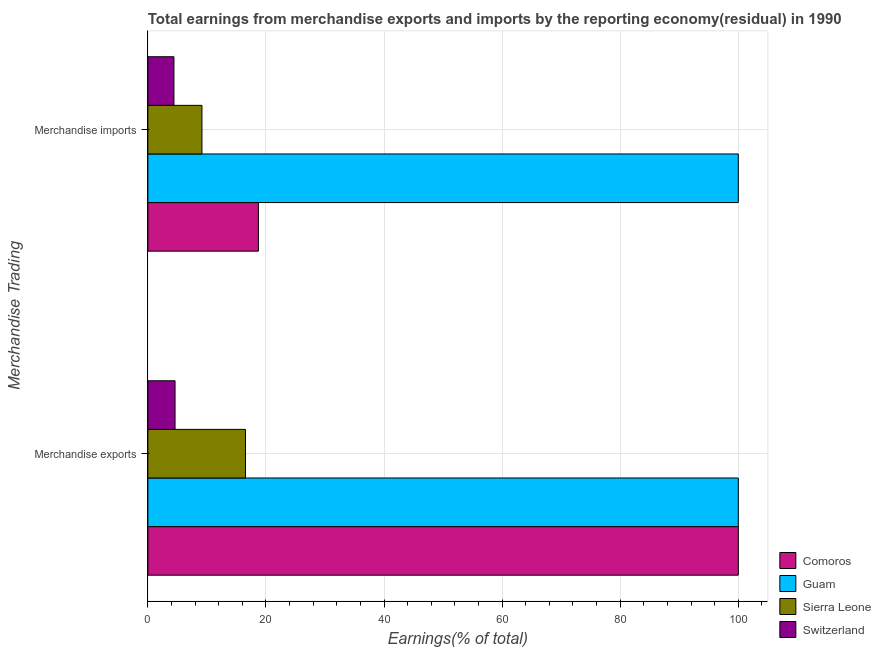How many different coloured bars are there?
Give a very brief answer. 4. How many groups of bars are there?
Ensure brevity in your answer.  2. Are the number of bars on each tick of the Y-axis equal?
Provide a succinct answer. Yes. How many bars are there on the 2nd tick from the top?
Offer a terse response. 4. What is the earnings from merchandise imports in Guam?
Offer a terse response. 100. Across all countries, what is the maximum earnings from merchandise imports?
Give a very brief answer. 100. Across all countries, what is the minimum earnings from merchandise exports?
Your answer should be compact. 4.61. In which country was the earnings from merchandise exports maximum?
Your response must be concise. Comoros. In which country was the earnings from merchandise imports minimum?
Offer a terse response. Switzerland. What is the total earnings from merchandise imports in the graph?
Your answer should be very brief. 132.3. What is the difference between the earnings from merchandise exports in Comoros and that in Guam?
Provide a succinct answer. 0. What is the difference between the earnings from merchandise exports in Guam and the earnings from merchandise imports in Switzerland?
Ensure brevity in your answer.  95.58. What is the average earnings from merchandise imports per country?
Provide a short and direct response. 33.07. What is the difference between the earnings from merchandise imports and earnings from merchandise exports in Comoros?
Offer a terse response. -81.28. In how many countries, is the earnings from merchandise exports greater than 40 %?
Ensure brevity in your answer.  2. What is the ratio of the earnings from merchandise exports in Sierra Leone to that in Guam?
Give a very brief answer. 0.17. Is the earnings from merchandise imports in Comoros less than that in Guam?
Ensure brevity in your answer.  Yes. In how many countries, is the earnings from merchandise exports greater than the average earnings from merchandise exports taken over all countries?
Offer a terse response. 2. What does the 1st bar from the top in Merchandise exports represents?
Offer a terse response. Switzerland. What does the 1st bar from the bottom in Merchandise exports represents?
Offer a terse response. Comoros. Are all the bars in the graph horizontal?
Your response must be concise. Yes. Does the graph contain any zero values?
Ensure brevity in your answer.  No. Where does the legend appear in the graph?
Your response must be concise. Bottom right. How are the legend labels stacked?
Your answer should be very brief. Vertical. What is the title of the graph?
Provide a succinct answer. Total earnings from merchandise exports and imports by the reporting economy(residual) in 1990. Does "Russian Federation" appear as one of the legend labels in the graph?
Give a very brief answer. No. What is the label or title of the X-axis?
Provide a short and direct response. Earnings(% of total). What is the label or title of the Y-axis?
Keep it short and to the point. Merchandise Trading. What is the Earnings(% of total) of Guam in Merchandise exports?
Your response must be concise. 100. What is the Earnings(% of total) in Sierra Leone in Merchandise exports?
Make the answer very short. 16.53. What is the Earnings(% of total) of Switzerland in Merchandise exports?
Ensure brevity in your answer.  4.61. What is the Earnings(% of total) in Comoros in Merchandise imports?
Provide a short and direct response. 18.72. What is the Earnings(% of total) in Sierra Leone in Merchandise imports?
Provide a short and direct response. 9.16. What is the Earnings(% of total) of Switzerland in Merchandise imports?
Ensure brevity in your answer.  4.42. Across all Merchandise Trading, what is the maximum Earnings(% of total) in Comoros?
Give a very brief answer. 100. Across all Merchandise Trading, what is the maximum Earnings(% of total) in Sierra Leone?
Offer a terse response. 16.53. Across all Merchandise Trading, what is the maximum Earnings(% of total) of Switzerland?
Your answer should be compact. 4.61. Across all Merchandise Trading, what is the minimum Earnings(% of total) in Comoros?
Your answer should be very brief. 18.72. Across all Merchandise Trading, what is the minimum Earnings(% of total) of Sierra Leone?
Your answer should be compact. 9.16. Across all Merchandise Trading, what is the minimum Earnings(% of total) in Switzerland?
Give a very brief answer. 4.42. What is the total Earnings(% of total) in Comoros in the graph?
Provide a succinct answer. 118.72. What is the total Earnings(% of total) of Guam in the graph?
Provide a short and direct response. 200. What is the total Earnings(% of total) of Sierra Leone in the graph?
Your answer should be compact. 25.69. What is the total Earnings(% of total) of Switzerland in the graph?
Offer a very short reply. 9.02. What is the difference between the Earnings(% of total) in Comoros in Merchandise exports and that in Merchandise imports?
Ensure brevity in your answer.  81.28. What is the difference between the Earnings(% of total) in Sierra Leone in Merchandise exports and that in Merchandise imports?
Provide a short and direct response. 7.37. What is the difference between the Earnings(% of total) of Switzerland in Merchandise exports and that in Merchandise imports?
Make the answer very short. 0.19. What is the difference between the Earnings(% of total) of Comoros in Merchandise exports and the Earnings(% of total) of Guam in Merchandise imports?
Provide a succinct answer. 0. What is the difference between the Earnings(% of total) in Comoros in Merchandise exports and the Earnings(% of total) in Sierra Leone in Merchandise imports?
Keep it short and to the point. 90.84. What is the difference between the Earnings(% of total) of Comoros in Merchandise exports and the Earnings(% of total) of Switzerland in Merchandise imports?
Ensure brevity in your answer.  95.58. What is the difference between the Earnings(% of total) of Guam in Merchandise exports and the Earnings(% of total) of Sierra Leone in Merchandise imports?
Make the answer very short. 90.84. What is the difference between the Earnings(% of total) in Guam in Merchandise exports and the Earnings(% of total) in Switzerland in Merchandise imports?
Give a very brief answer. 95.58. What is the difference between the Earnings(% of total) of Sierra Leone in Merchandise exports and the Earnings(% of total) of Switzerland in Merchandise imports?
Offer a terse response. 12.12. What is the average Earnings(% of total) in Comoros per Merchandise Trading?
Offer a terse response. 59.36. What is the average Earnings(% of total) of Guam per Merchandise Trading?
Make the answer very short. 100. What is the average Earnings(% of total) in Sierra Leone per Merchandise Trading?
Keep it short and to the point. 12.85. What is the average Earnings(% of total) in Switzerland per Merchandise Trading?
Offer a terse response. 4.51. What is the difference between the Earnings(% of total) of Comoros and Earnings(% of total) of Sierra Leone in Merchandise exports?
Your response must be concise. 83.47. What is the difference between the Earnings(% of total) in Comoros and Earnings(% of total) in Switzerland in Merchandise exports?
Keep it short and to the point. 95.39. What is the difference between the Earnings(% of total) of Guam and Earnings(% of total) of Sierra Leone in Merchandise exports?
Give a very brief answer. 83.47. What is the difference between the Earnings(% of total) in Guam and Earnings(% of total) in Switzerland in Merchandise exports?
Offer a very short reply. 95.39. What is the difference between the Earnings(% of total) in Sierra Leone and Earnings(% of total) in Switzerland in Merchandise exports?
Keep it short and to the point. 11.93. What is the difference between the Earnings(% of total) of Comoros and Earnings(% of total) of Guam in Merchandise imports?
Keep it short and to the point. -81.28. What is the difference between the Earnings(% of total) of Comoros and Earnings(% of total) of Sierra Leone in Merchandise imports?
Give a very brief answer. 9.56. What is the difference between the Earnings(% of total) in Comoros and Earnings(% of total) in Switzerland in Merchandise imports?
Your response must be concise. 14.31. What is the difference between the Earnings(% of total) of Guam and Earnings(% of total) of Sierra Leone in Merchandise imports?
Provide a short and direct response. 90.84. What is the difference between the Earnings(% of total) of Guam and Earnings(% of total) of Switzerland in Merchandise imports?
Your response must be concise. 95.58. What is the difference between the Earnings(% of total) of Sierra Leone and Earnings(% of total) of Switzerland in Merchandise imports?
Make the answer very short. 4.74. What is the ratio of the Earnings(% of total) of Comoros in Merchandise exports to that in Merchandise imports?
Keep it short and to the point. 5.34. What is the ratio of the Earnings(% of total) in Guam in Merchandise exports to that in Merchandise imports?
Give a very brief answer. 1. What is the ratio of the Earnings(% of total) of Sierra Leone in Merchandise exports to that in Merchandise imports?
Offer a terse response. 1.81. What is the ratio of the Earnings(% of total) of Switzerland in Merchandise exports to that in Merchandise imports?
Offer a terse response. 1.04. What is the difference between the highest and the second highest Earnings(% of total) in Comoros?
Make the answer very short. 81.28. What is the difference between the highest and the second highest Earnings(% of total) of Guam?
Make the answer very short. 0. What is the difference between the highest and the second highest Earnings(% of total) of Sierra Leone?
Offer a terse response. 7.37. What is the difference between the highest and the second highest Earnings(% of total) in Switzerland?
Provide a short and direct response. 0.19. What is the difference between the highest and the lowest Earnings(% of total) in Comoros?
Provide a short and direct response. 81.28. What is the difference between the highest and the lowest Earnings(% of total) in Sierra Leone?
Provide a succinct answer. 7.37. What is the difference between the highest and the lowest Earnings(% of total) in Switzerland?
Offer a very short reply. 0.19. 